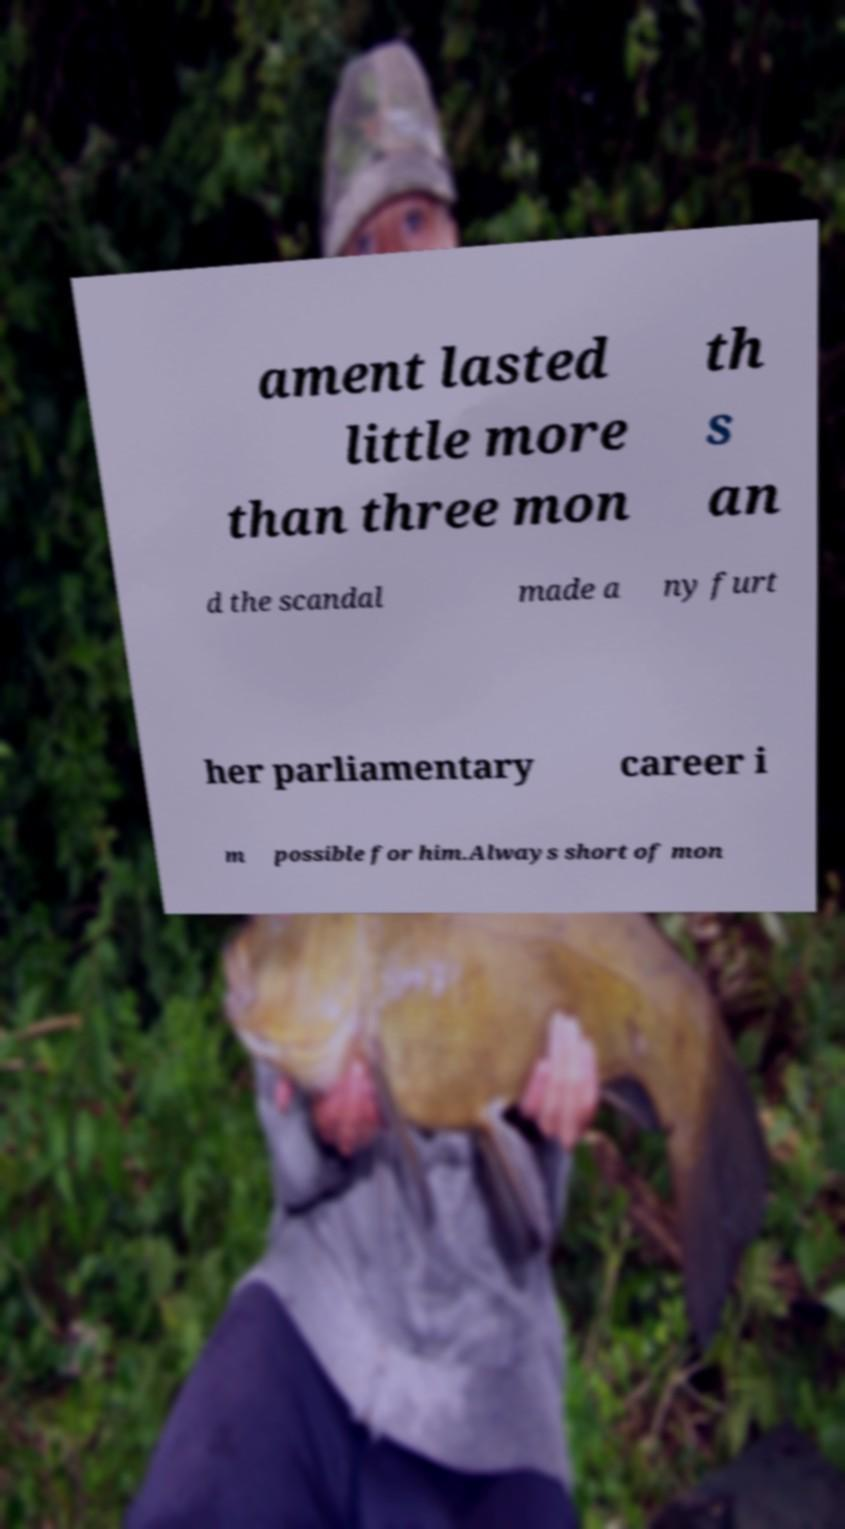Please identify and transcribe the text found in this image. ament lasted little more than three mon th s an d the scandal made a ny furt her parliamentary career i m possible for him.Always short of mon 